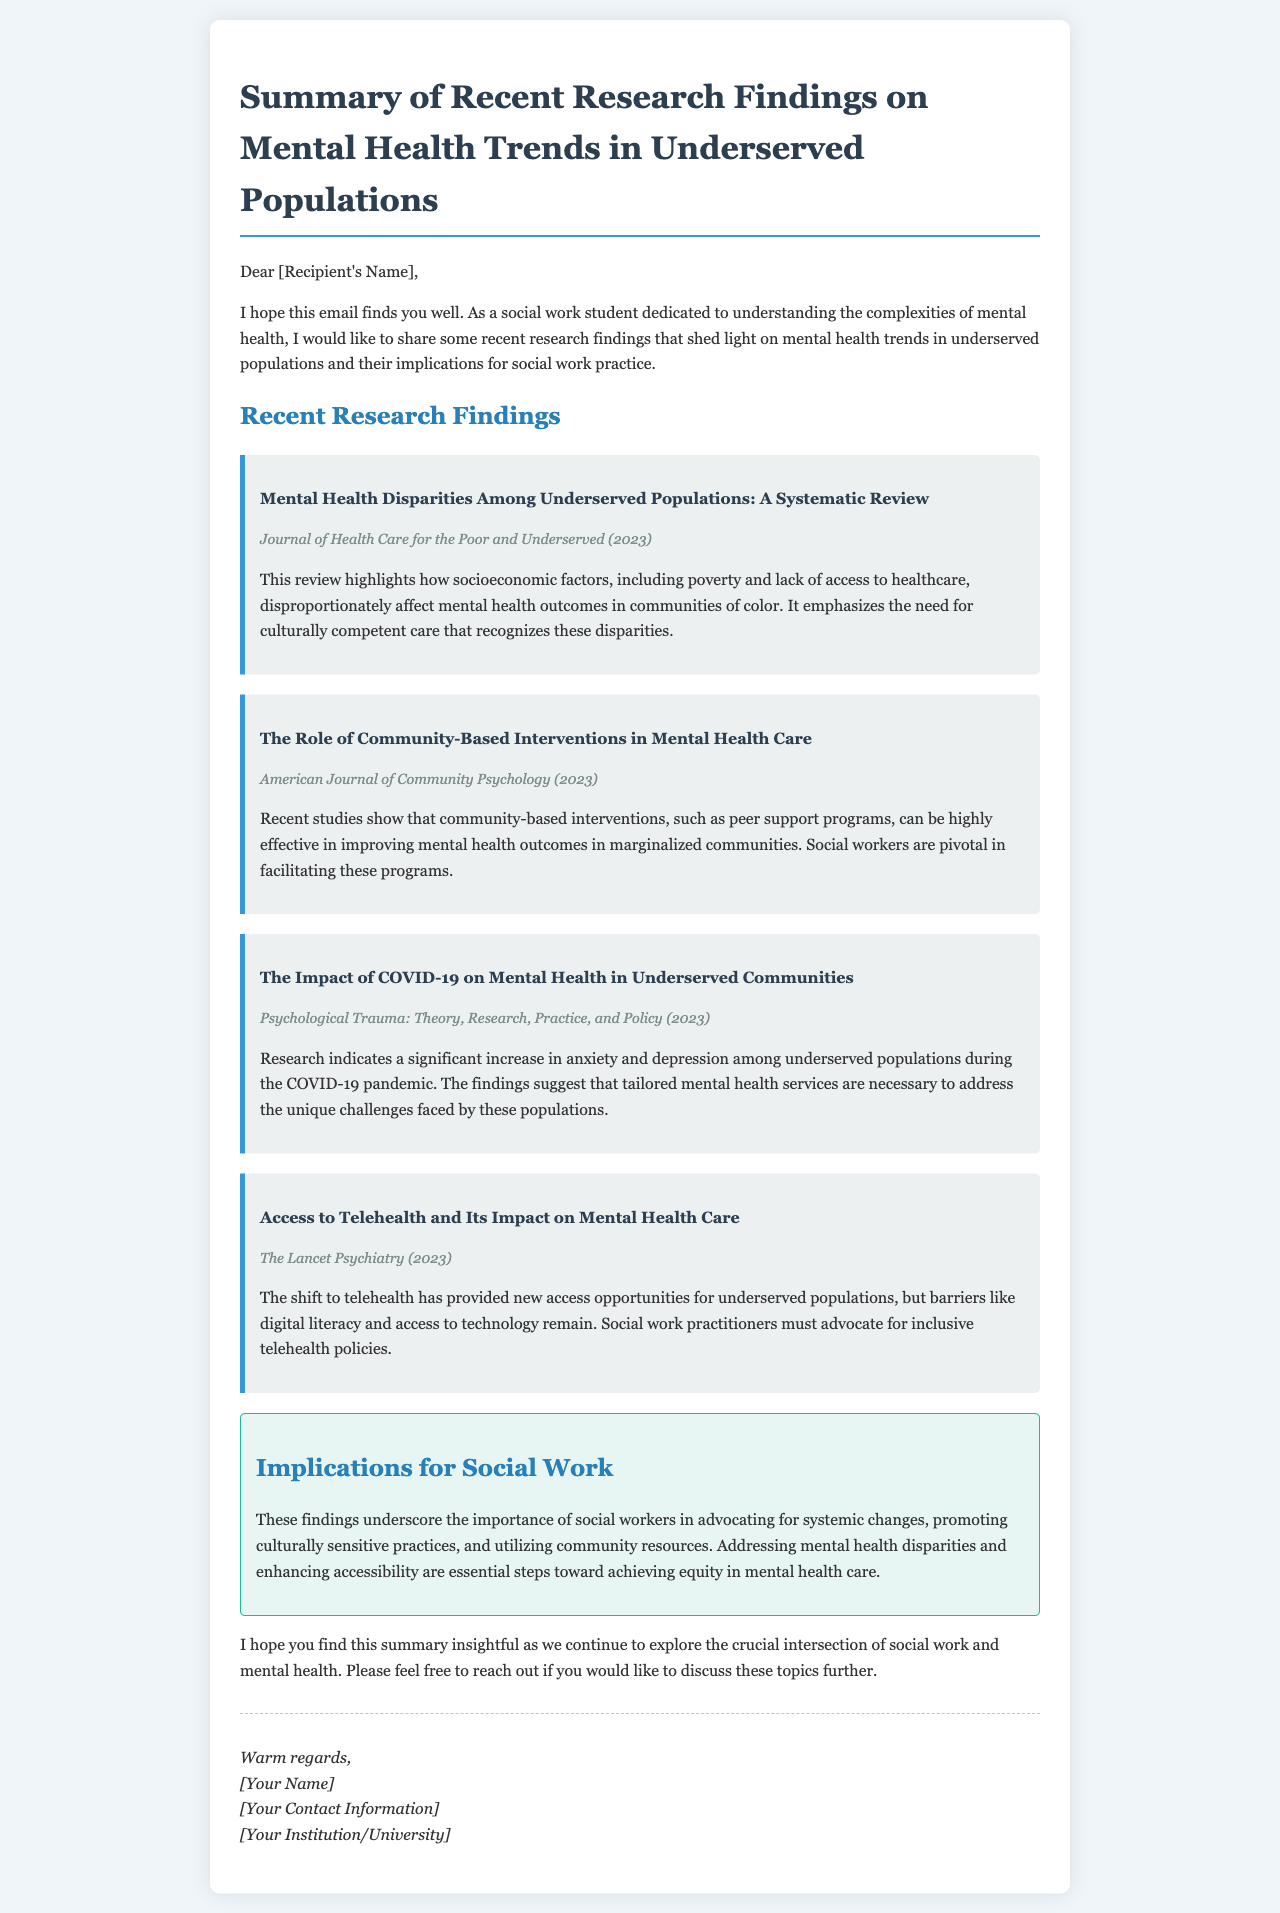What is the title of the first research finding? The title of the first research finding is stated in the section for recent research findings.
Answer: Mental Health Disparities Among Underserved Populations: A Systematic Review In which journal was the first research finding published? The journal name can be found right after the title of the first research finding.
Answer: Journal of Health Care for the Poor and Underserved What year was the review titled "The Role of Community-Based Interventions in Mental Health Care" published? Each research finding includes the publication year in parentheses after the journal name.
Answer: 2023 What are the implications for social work mentioned in the document? The implications section outlines the main points regarding the role of social workers based on research findings.
Answer: Advocating for systemic changes, promoting culturally sensitive practices, and utilizing community resources Which population saw a significant increase in anxiety and depression during COVID-19? The research finding details the specific population affected during the pandemic in its title and description.
Answer: Underserved populations 